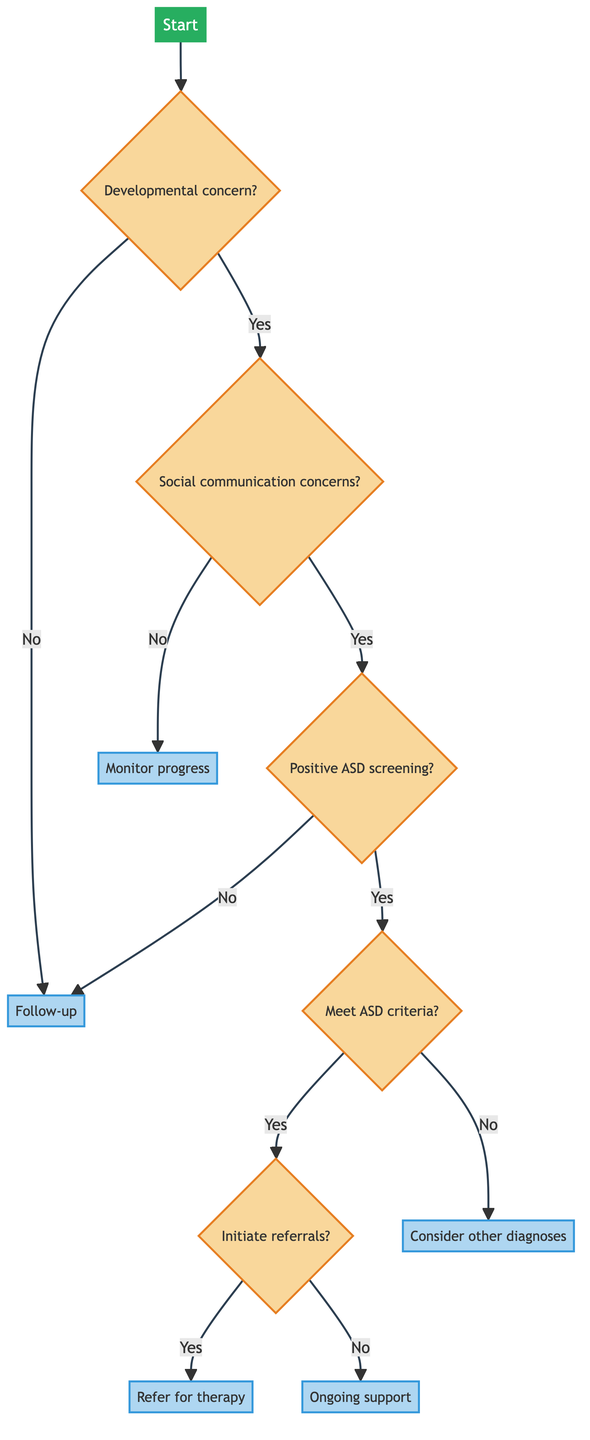What is the starting point of the decision tree? The starting point is labeled "Start".
Answer: Start How many main pathways are initiated after the first question? There are two main pathways: "Yes" and "No" from the first question about developmental concerns.
Answer: 2 If there are no developmental concerns, what is the outcome? The outcome is that the patient should have a "Follow-up".
Answer: Follow-up What action is taken if specific concerns about social communication skills are present? If there are concerns, the next step is to proceed to "screening_ASD".
Answer: screening_ASD What process is undertaken if the patient meets ASD criteria based on the DSM-5? If ASD criteria are met, the process involves initiating referrals for therapy.
Answer: Refer for therapy What is the next step if the Autism Screening Tool yields a negative result? If the screening result is negative, the outcome is to "follow-up".
Answer: follow-up How many total processes are listed in the diagram? There are six processes in total that represent the outcomes at various stages.
Answer: 6 What is the final action taken if the patient does not meet ASD criteria? If the patient does not meet the criteria, the action is to "consider other diagnoses".
Answer: Consider other diagnoses What happens if a diagnosis of ASD is established and referrals are not initiated? If referrals are not initiated, the outcome is "ongoing support".
Answer: ongoing support 